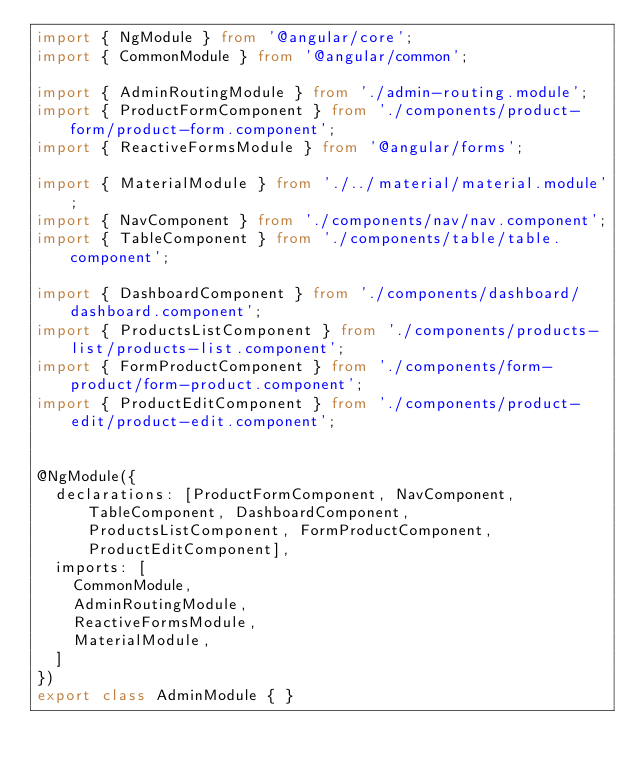<code> <loc_0><loc_0><loc_500><loc_500><_TypeScript_>import { NgModule } from '@angular/core';
import { CommonModule } from '@angular/common';

import { AdminRoutingModule } from './admin-routing.module';
import { ProductFormComponent } from './components/product-form/product-form.component';
import { ReactiveFormsModule } from '@angular/forms';

import { MaterialModule } from './../material/material.module';
import { NavComponent } from './components/nav/nav.component';
import { TableComponent } from './components/table/table.component';

import { DashboardComponent } from './components/dashboard/dashboard.component';
import { ProductsListComponent } from './components/products-list/products-list.component';
import { FormProductComponent } from './components/form-product/form-product.component';
import { ProductEditComponent } from './components/product-edit/product-edit.component';


@NgModule({
  declarations: [ProductFormComponent, NavComponent, TableComponent, DashboardComponent, ProductsListComponent, FormProductComponent, ProductEditComponent],
  imports: [
    CommonModule,
    AdminRoutingModule,
    ReactiveFormsModule,
    MaterialModule,
  ]
})
export class AdminModule { }
</code> 